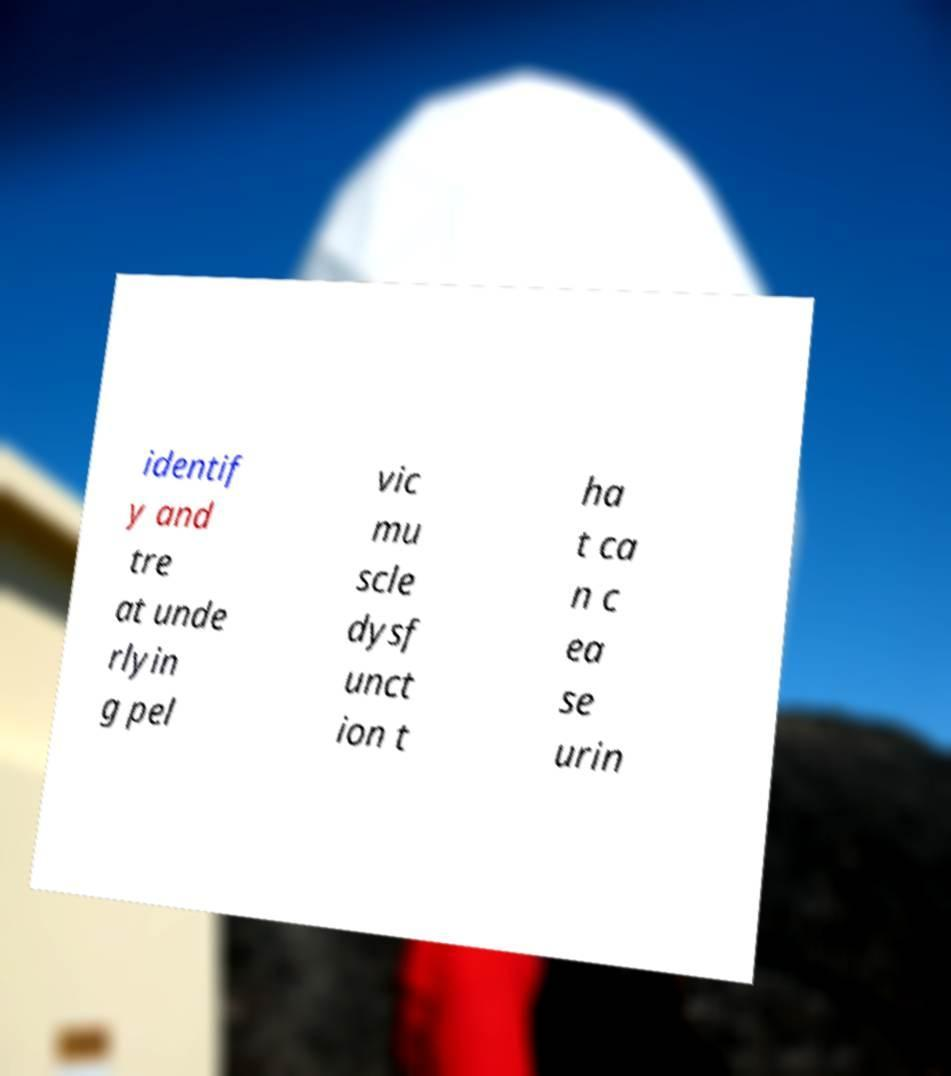What messages or text are displayed in this image? I need them in a readable, typed format. identif y and tre at unde rlyin g pel vic mu scle dysf unct ion t ha t ca n c ea se urin 